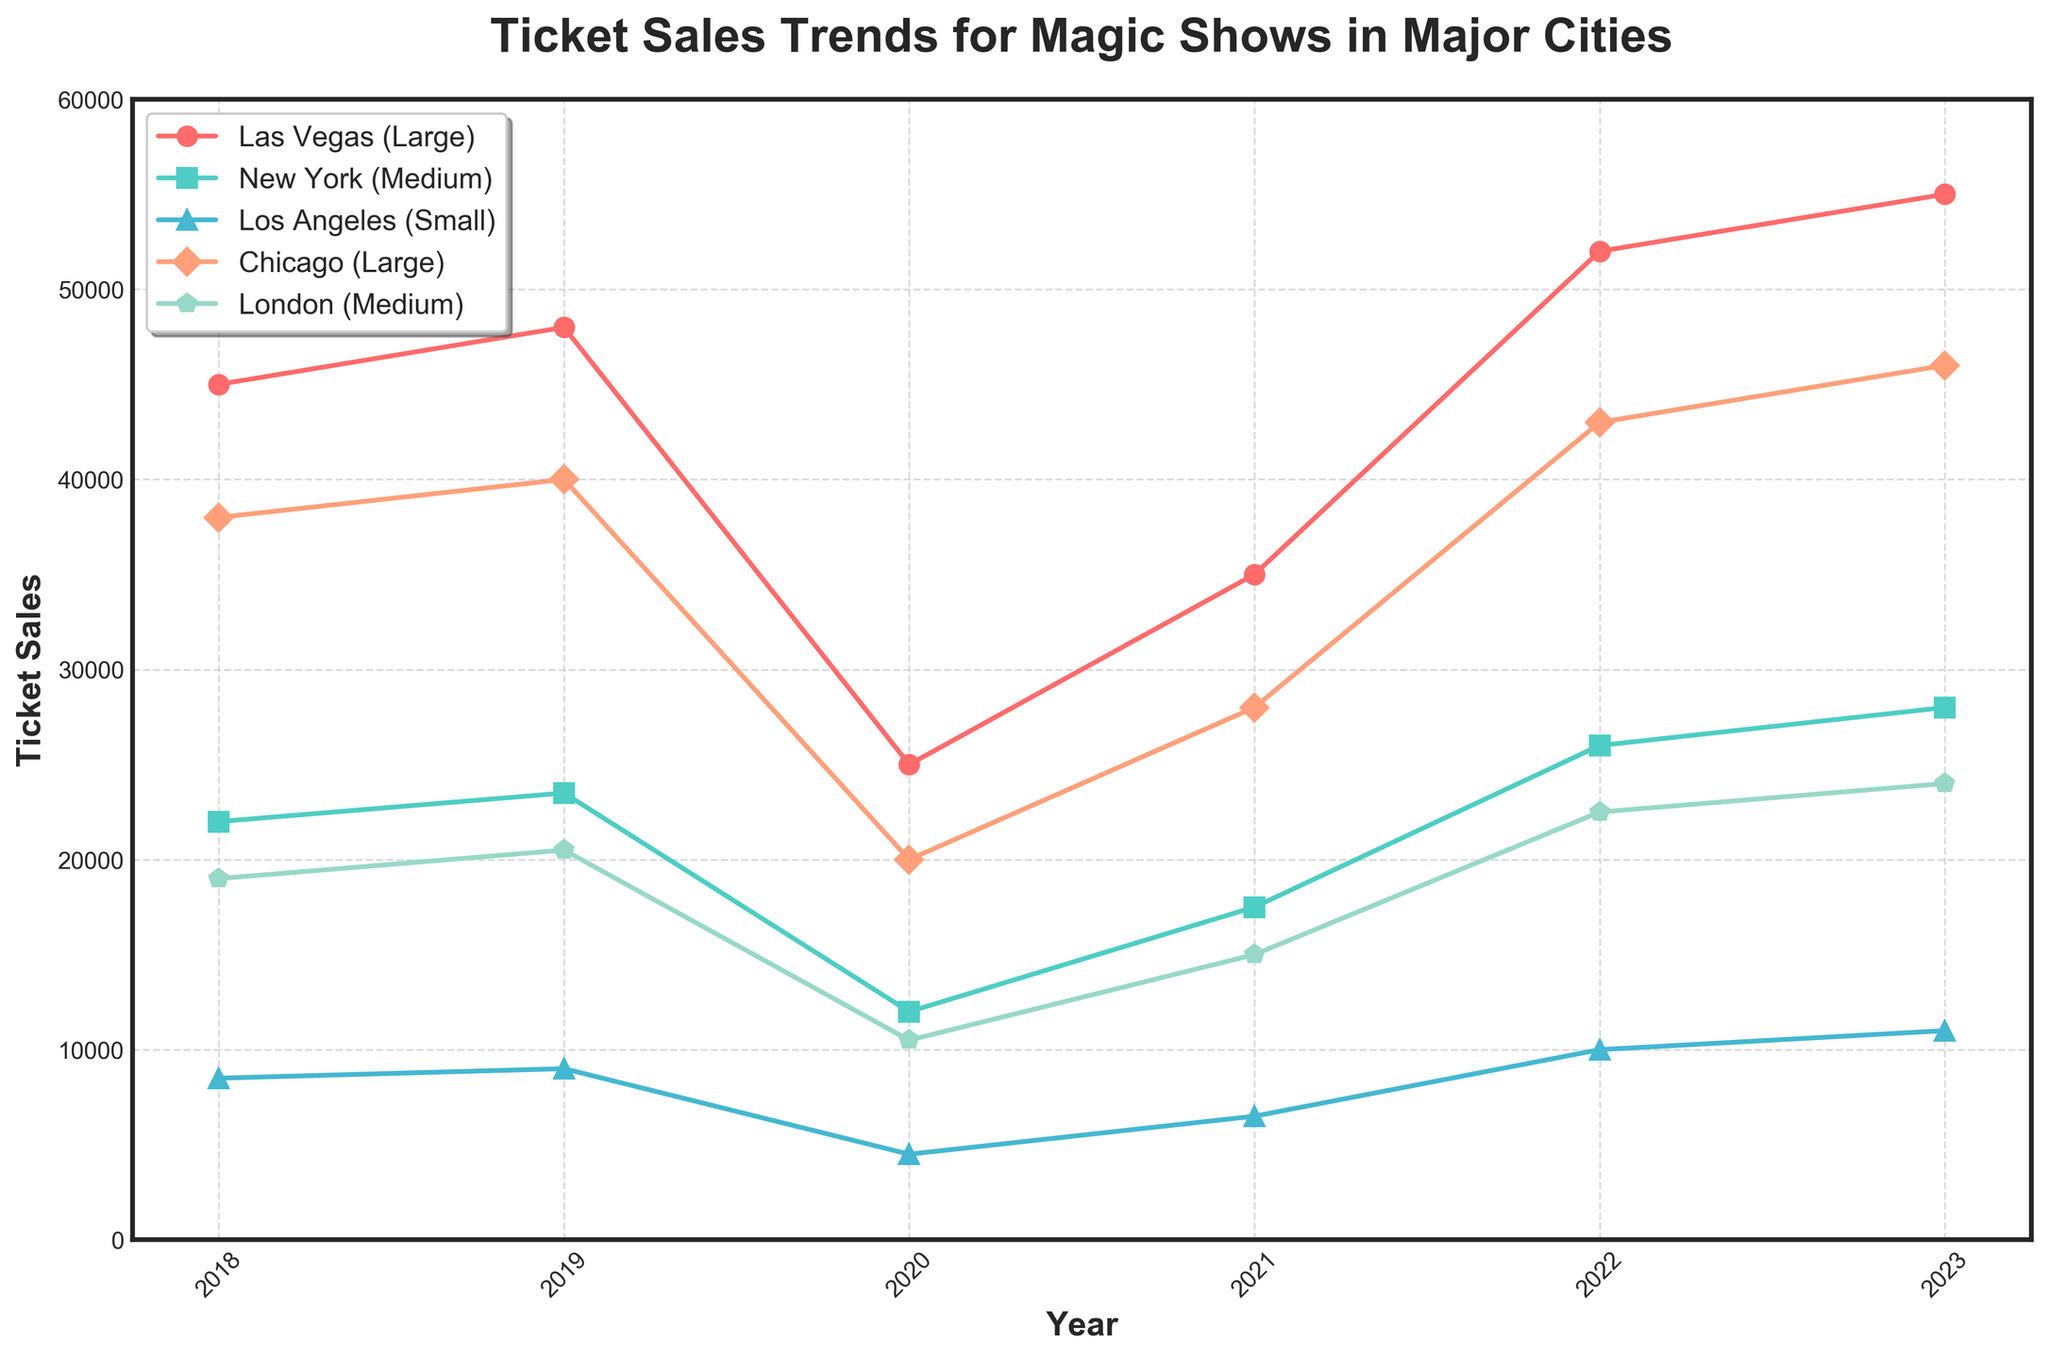What's the highest ticket sale value recorded for Las Vegas (Large) in the data? Look at the line representing Las Vegas (Large). The peak of this line on the y-axis indicates the highest ticket sales value, which occurs in 2023.
Answer: 55,000 Which year saw the lowest ticket sales for Los Angeles (Small)? Identify the line for Los Angeles (Small), marked by specific color and marker. The lowest point of this line, occurring in 2020, shows the lowest sales.
Answer: 2020 How much did ticket sales for Chicago (Large) increase from 2021 to 2022? Find the Chicago (Large) line and compare the values at 2021 and 2022. Subtract the 2021 value from the 2022 value: 43000 - 28000 = 15000.
Answer: 15,000 What is the average ticket sales for New York (Medium) from 2019 to 2022? Sum the values for New York (Medium) for each year from 2019 to 2022 and then divide by 4. (23500 + 12000 + 17500 + 26000) / 4 = 19750.
Answer: 19,750 Compare the ticket sales for London (Medium) and New York (Medium) in 2023. Which one has higher sales? Look at the ticket sales values for both London and New York in 2023. Compare the numbers: New York has 28000 whereas London has 24000. New York is higher.
Answer: New York (Medium) Which city experienced a significant drop in ticket sales in 2020? Each line should be checked to identify a significant drop in value from 2019 to 2020. Las Vegas (Large) and London (Medium) both show noticeable drops, with the largest impact visible in Las Vegas (Large).
Answer: Las Vegas (Large) How many years did Chicago (Large) have higher ticket sales than London (Medium)? Compare yearly ticket sales values for Chicago and London. Chicago has higher values in 2018, 2019, 2021, 2022, and 2023. That's five years.
Answer: 5 What is the total ticket sales for Los Angeles (Small) over the provided years? Sum up the ticket sales values for Los Angeles for all years: 8500 + 9000 + 4500 + 6500 + 10000 + 11000 = 49500.
Answer: 49,500 By how much did ticket sales for Las Vegas (Large) increase from 2018 to 2023? Compare the 2018 and 2023 ticket sales for Las Vegas: 55000 - 45000 = 10000.
Answer: 10,000 What is the overall trend of ticket sales for all cities combined between 2020 and 2023? Add up the ticket sales values for all cities for each year from 2020 to 2023. Analyze the summed values to determine if there is an increasing, decreasing, or stable trend. Sales: 25000+12000+4500+20000+10500 = 72000 (2020), 35000+17500+6500+28000+15000 = 102000 (2021), 52000+26000+10000+43000+22500 = 153500 (2022), 55000+28000+11000+46000+24000 = 164000 (2023). There's a consistent increase in ticket sales.
Answer: Increasing 